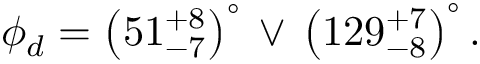Convert formula to latex. <formula><loc_0><loc_0><loc_500><loc_500>\phi _ { d } = \left ( 5 1 _ { - 7 } ^ { + 8 } \right ) ^ { \circ } \, \lor \, \left ( 1 2 9 _ { - 8 } ^ { + 7 } \right ) ^ { \circ } .</formula> 